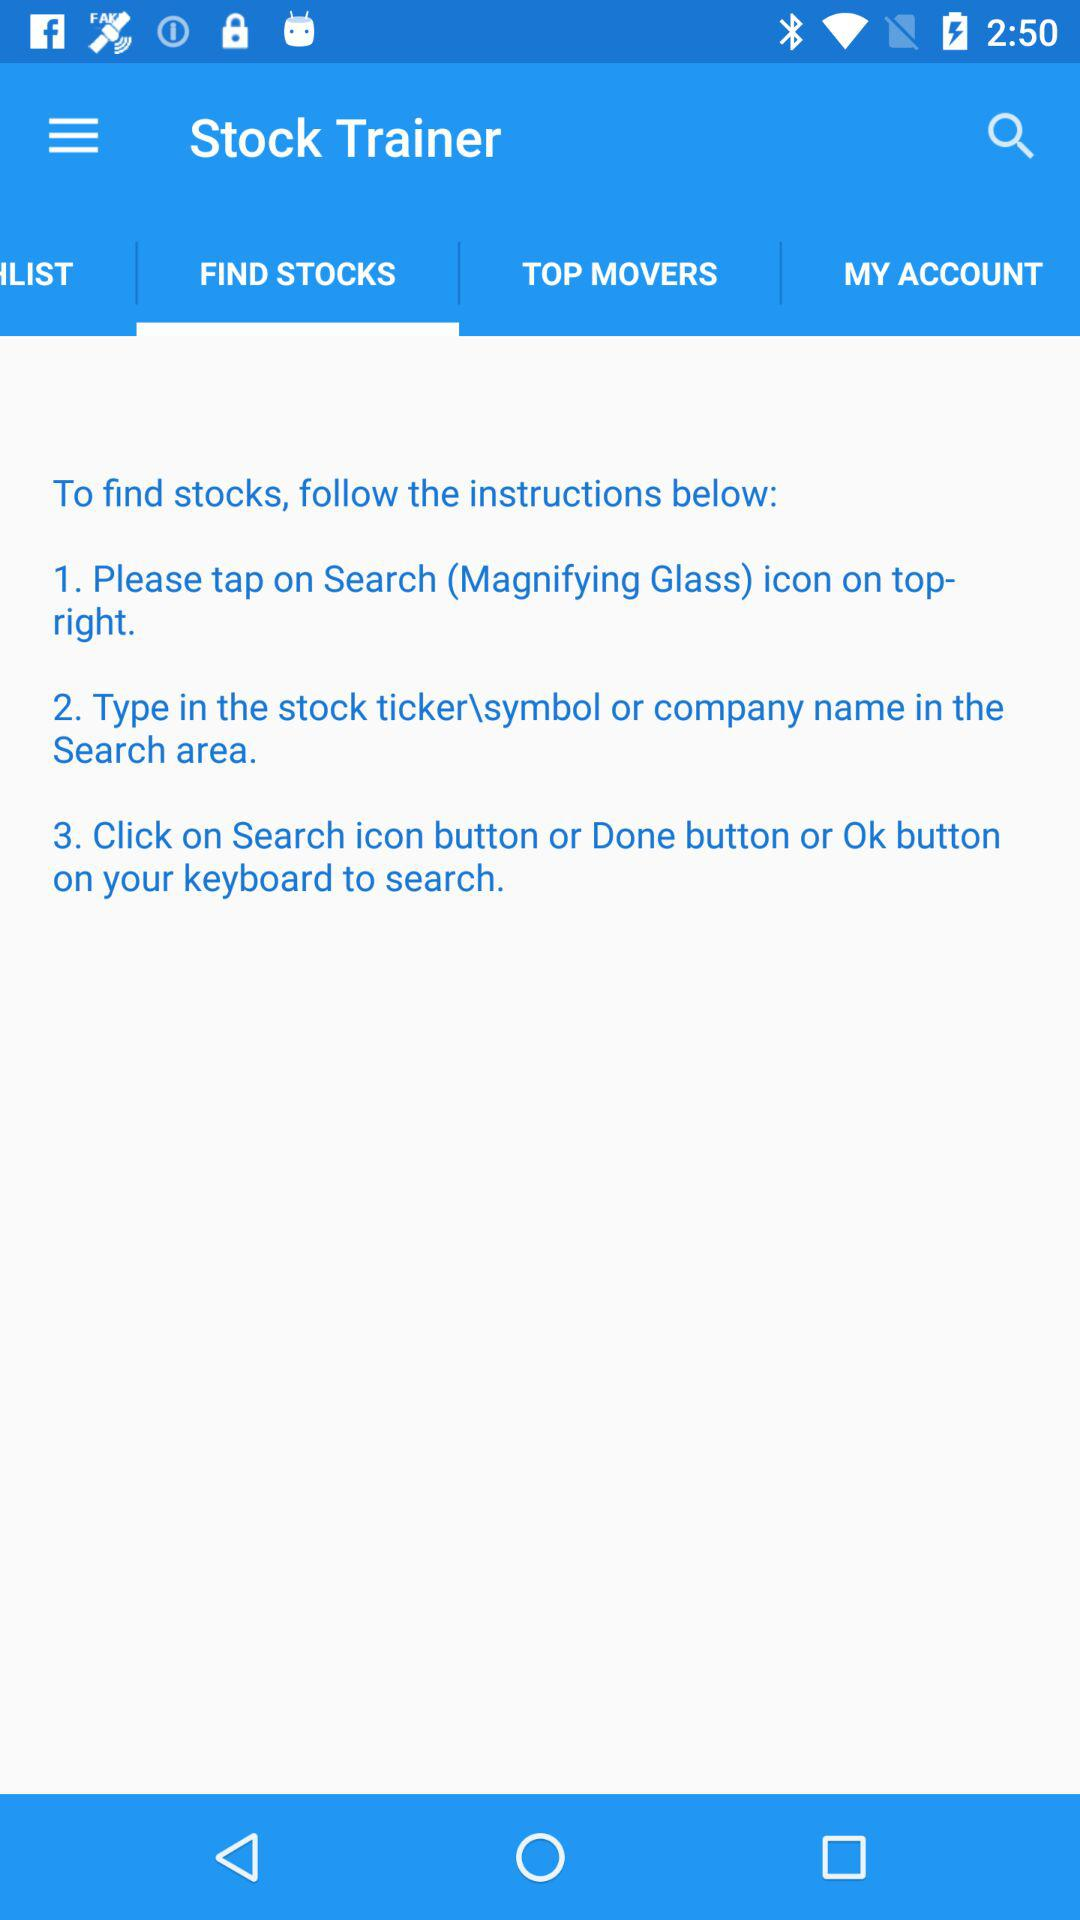How many instructions are there to find stocks?
Answer the question using a single word or phrase. 3 